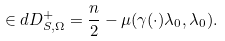Convert formula to latex. <formula><loc_0><loc_0><loc_500><loc_500>\in d D _ { S , \Omega } ^ { + } = \frac { n } { 2 } - \mu ( \gamma ( \cdot ) \lambda _ { 0 } , \lambda _ { 0 } ) .</formula> 